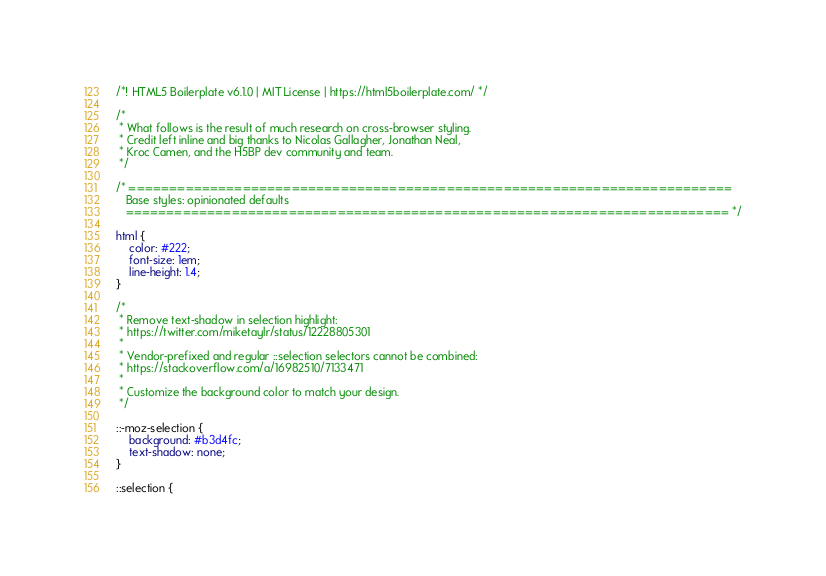<code> <loc_0><loc_0><loc_500><loc_500><_CSS_>/*! HTML5 Boilerplate v6.1.0 | MIT License | https://html5boilerplate.com/ */

/*
 * What follows is the result of much research on cross-browser styling.
 * Credit left inline and big thanks to Nicolas Gallagher, Jonathan Neal,
 * Kroc Camen, and the H5BP dev community and team.
 */

/* ==========================================================================
   Base styles: opinionated defaults
   ========================================================================== */

html {
    color: #222;
    font-size: 1em;
    line-height: 1.4;
}

/*
 * Remove text-shadow in selection highlight:
 * https://twitter.com/miketaylr/status/12228805301
 *
 * Vendor-prefixed and regular ::selection selectors cannot be combined:
 * https://stackoverflow.com/a/16982510/7133471
 *
 * Customize the background color to match your design.
 */

::-moz-selection {
    background: #b3d4fc;
    text-shadow: none;
}

::selection {</code> 